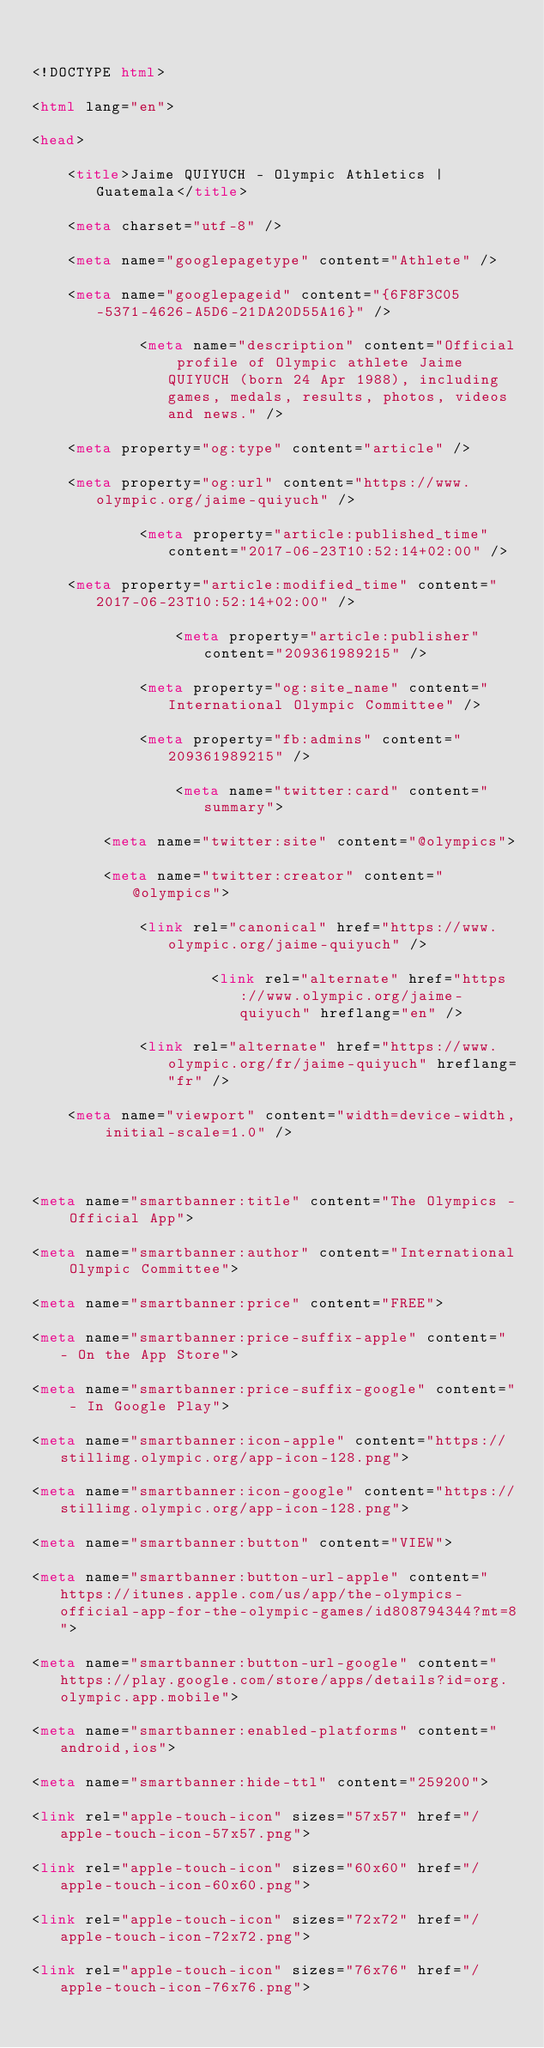<code> <loc_0><loc_0><loc_500><loc_500><_HTML_>
<!DOCTYPE html>
<html lang="en">
<head>
    <title>Jaime QUIYUCH - Olympic Athletics | Guatemala</title>
    <meta charset="utf-8" />
    <meta name="googlepagetype" content="Athlete" />
    <meta name="googlepageid" content="{6F8F3C05-5371-4626-A5D6-21DA20D55A16}" />
            <meta name="description" content="Official profile of Olympic athlete Jaime QUIYUCH (born 24 Apr 1988), including games, medals, results, photos, videos and news." />
    <meta property="og:type" content="article" />
    <meta property="og:url" content="https://www.olympic.org/jaime-quiyuch" />
            <meta property="article:published_time" content="2017-06-23T10:52:14+02:00" />
    <meta property="article:modified_time" content="2017-06-23T10:52:14+02:00" />
                <meta property="article:publisher" content="209361989215" />
            <meta property="og:site_name" content="International Olympic Committee" />
            <meta property="fb:admins" content="209361989215" />
                <meta name="twitter:card" content="summary">
        <meta name="twitter:site" content="@olympics">
        <meta name="twitter:creator" content="@olympics">
            <link rel="canonical" href="https://www.olympic.org/jaime-quiyuch" />
                    <link rel="alternate" href="https://www.olympic.org/jaime-quiyuch" hreflang="en" />
            <link rel="alternate" href="https://www.olympic.org/fr/jaime-quiyuch" hreflang="fr" />
    <meta name="viewport" content="width=device-width, initial-scale=1.0" />

<meta name="smartbanner:title" content="The Olympics - Official App">
<meta name="smartbanner:author" content="International Olympic Committee">
<meta name="smartbanner:price" content="FREE">
<meta name="smartbanner:price-suffix-apple" content=" - On the App Store">
<meta name="smartbanner:price-suffix-google" content=" - In Google Play">
<meta name="smartbanner:icon-apple" content="https://stillimg.olympic.org/app-icon-128.png">
<meta name="smartbanner:icon-google" content="https://stillimg.olympic.org/app-icon-128.png">
<meta name="smartbanner:button" content="VIEW">
<meta name="smartbanner:button-url-apple" content="https://itunes.apple.com/us/app/the-olympics-official-app-for-the-olympic-games/id808794344?mt=8">
<meta name="smartbanner:button-url-google" content="https://play.google.com/store/apps/details?id=org.olympic.app.mobile">
<meta name="smartbanner:enabled-platforms" content="android,ios">
<meta name="smartbanner:hide-ttl" content="259200">
<link rel="apple-touch-icon" sizes="57x57" href="/apple-touch-icon-57x57.png">
<link rel="apple-touch-icon" sizes="60x60" href="/apple-touch-icon-60x60.png">
<link rel="apple-touch-icon" sizes="72x72" href="/apple-touch-icon-72x72.png">
<link rel="apple-touch-icon" sizes="76x76" href="/apple-touch-icon-76x76.png"></code> 